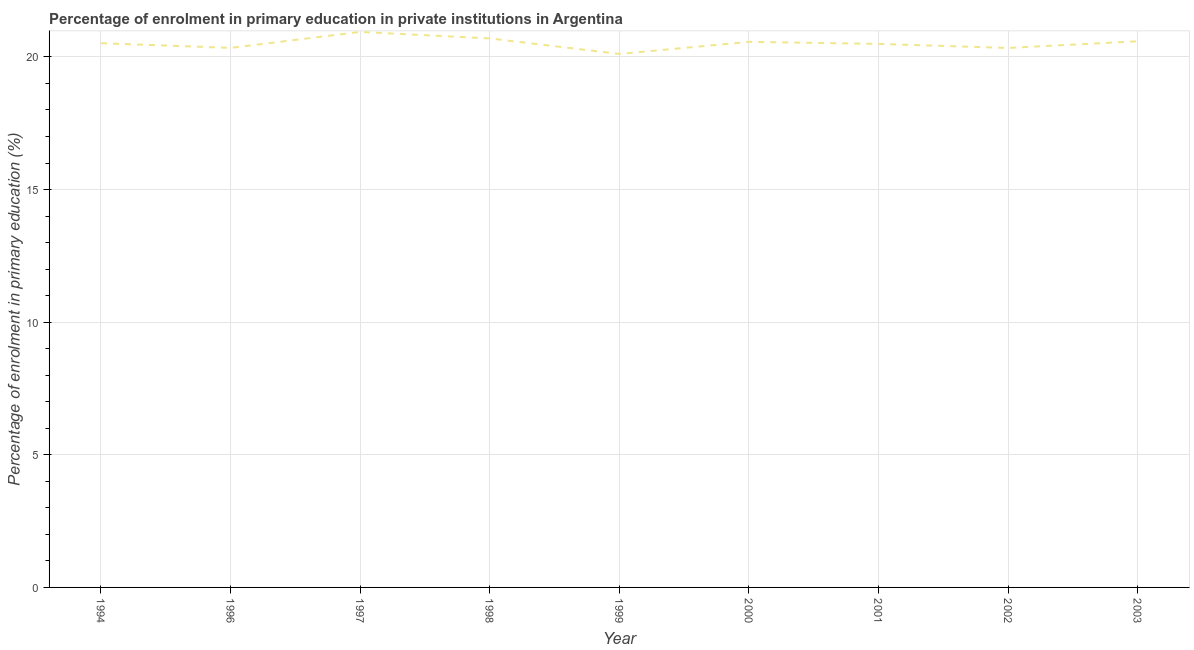What is the enrolment percentage in primary education in 1999?
Give a very brief answer. 20.11. Across all years, what is the maximum enrolment percentage in primary education?
Offer a very short reply. 20.94. Across all years, what is the minimum enrolment percentage in primary education?
Provide a succinct answer. 20.11. In which year was the enrolment percentage in primary education maximum?
Provide a short and direct response. 1997. In which year was the enrolment percentage in primary education minimum?
Your answer should be very brief. 1999. What is the sum of the enrolment percentage in primary education?
Keep it short and to the point. 184.6. What is the difference between the enrolment percentage in primary education in 1994 and 2003?
Your answer should be compact. -0.07. What is the average enrolment percentage in primary education per year?
Your response must be concise. 20.51. What is the median enrolment percentage in primary education?
Your answer should be compact. 20.52. What is the ratio of the enrolment percentage in primary education in 2002 to that in 2003?
Ensure brevity in your answer.  0.99. What is the difference between the highest and the second highest enrolment percentage in primary education?
Keep it short and to the point. 0.24. What is the difference between the highest and the lowest enrolment percentage in primary education?
Your answer should be compact. 0.83. In how many years, is the enrolment percentage in primary education greater than the average enrolment percentage in primary education taken over all years?
Provide a succinct answer. 5. Are the values on the major ticks of Y-axis written in scientific E-notation?
Provide a succinct answer. No. Does the graph contain any zero values?
Give a very brief answer. No. Does the graph contain grids?
Offer a terse response. Yes. What is the title of the graph?
Offer a very short reply. Percentage of enrolment in primary education in private institutions in Argentina. What is the label or title of the Y-axis?
Provide a short and direct response. Percentage of enrolment in primary education (%). What is the Percentage of enrolment in primary education (%) of 1994?
Provide a succinct answer. 20.52. What is the Percentage of enrolment in primary education (%) in 1996?
Offer a terse response. 20.34. What is the Percentage of enrolment in primary education (%) of 1997?
Keep it short and to the point. 20.94. What is the Percentage of enrolment in primary education (%) of 1998?
Your answer should be very brief. 20.7. What is the Percentage of enrolment in primary education (%) of 1999?
Ensure brevity in your answer.  20.11. What is the Percentage of enrolment in primary education (%) in 2000?
Keep it short and to the point. 20.57. What is the Percentage of enrolment in primary education (%) of 2001?
Offer a very short reply. 20.49. What is the Percentage of enrolment in primary education (%) of 2002?
Offer a very short reply. 20.34. What is the Percentage of enrolment in primary education (%) in 2003?
Make the answer very short. 20.59. What is the difference between the Percentage of enrolment in primary education (%) in 1994 and 1996?
Ensure brevity in your answer.  0.18. What is the difference between the Percentage of enrolment in primary education (%) in 1994 and 1997?
Make the answer very short. -0.43. What is the difference between the Percentage of enrolment in primary education (%) in 1994 and 1998?
Provide a short and direct response. -0.18. What is the difference between the Percentage of enrolment in primary education (%) in 1994 and 1999?
Your answer should be very brief. 0.41. What is the difference between the Percentage of enrolment in primary education (%) in 1994 and 2000?
Your answer should be compact. -0.05. What is the difference between the Percentage of enrolment in primary education (%) in 1994 and 2001?
Offer a very short reply. 0.03. What is the difference between the Percentage of enrolment in primary education (%) in 1994 and 2002?
Your answer should be very brief. 0.18. What is the difference between the Percentage of enrolment in primary education (%) in 1994 and 2003?
Keep it short and to the point. -0.07. What is the difference between the Percentage of enrolment in primary education (%) in 1996 and 1997?
Give a very brief answer. -0.6. What is the difference between the Percentage of enrolment in primary education (%) in 1996 and 1998?
Your answer should be very brief. -0.36. What is the difference between the Percentage of enrolment in primary education (%) in 1996 and 1999?
Your response must be concise. 0.23. What is the difference between the Percentage of enrolment in primary education (%) in 1996 and 2000?
Keep it short and to the point. -0.23. What is the difference between the Percentage of enrolment in primary education (%) in 1996 and 2001?
Provide a succinct answer. -0.15. What is the difference between the Percentage of enrolment in primary education (%) in 1996 and 2002?
Your answer should be compact. 0. What is the difference between the Percentage of enrolment in primary education (%) in 1996 and 2003?
Your answer should be very brief. -0.25. What is the difference between the Percentage of enrolment in primary education (%) in 1997 and 1998?
Offer a very short reply. 0.24. What is the difference between the Percentage of enrolment in primary education (%) in 1997 and 1999?
Give a very brief answer. 0.83. What is the difference between the Percentage of enrolment in primary education (%) in 1997 and 2000?
Keep it short and to the point. 0.37. What is the difference between the Percentage of enrolment in primary education (%) in 1997 and 2001?
Make the answer very short. 0.45. What is the difference between the Percentage of enrolment in primary education (%) in 1997 and 2002?
Make the answer very short. 0.6. What is the difference between the Percentage of enrolment in primary education (%) in 1997 and 2003?
Ensure brevity in your answer.  0.35. What is the difference between the Percentage of enrolment in primary education (%) in 1998 and 1999?
Your answer should be compact. 0.59. What is the difference between the Percentage of enrolment in primary education (%) in 1998 and 2000?
Offer a terse response. 0.13. What is the difference between the Percentage of enrolment in primary education (%) in 1998 and 2001?
Give a very brief answer. 0.21. What is the difference between the Percentage of enrolment in primary education (%) in 1998 and 2002?
Provide a short and direct response. 0.36. What is the difference between the Percentage of enrolment in primary education (%) in 1998 and 2003?
Your answer should be compact. 0.11. What is the difference between the Percentage of enrolment in primary education (%) in 1999 and 2000?
Your answer should be very brief. -0.46. What is the difference between the Percentage of enrolment in primary education (%) in 1999 and 2001?
Your response must be concise. -0.38. What is the difference between the Percentage of enrolment in primary education (%) in 1999 and 2002?
Offer a terse response. -0.23. What is the difference between the Percentage of enrolment in primary education (%) in 1999 and 2003?
Your response must be concise. -0.48. What is the difference between the Percentage of enrolment in primary education (%) in 2000 and 2001?
Your answer should be very brief. 0.08. What is the difference between the Percentage of enrolment in primary education (%) in 2000 and 2002?
Keep it short and to the point. 0.23. What is the difference between the Percentage of enrolment in primary education (%) in 2000 and 2003?
Make the answer very short. -0.02. What is the difference between the Percentage of enrolment in primary education (%) in 2001 and 2002?
Provide a short and direct response. 0.15. What is the difference between the Percentage of enrolment in primary education (%) in 2001 and 2003?
Your response must be concise. -0.1. What is the difference between the Percentage of enrolment in primary education (%) in 2002 and 2003?
Keep it short and to the point. -0.25. What is the ratio of the Percentage of enrolment in primary education (%) in 1994 to that in 2000?
Your response must be concise. 1. What is the ratio of the Percentage of enrolment in primary education (%) in 1994 to that in 2001?
Your answer should be very brief. 1. What is the ratio of the Percentage of enrolment in primary education (%) in 1994 to that in 2002?
Keep it short and to the point. 1.01. What is the ratio of the Percentage of enrolment in primary education (%) in 1996 to that in 1999?
Your response must be concise. 1.01. What is the ratio of the Percentage of enrolment in primary education (%) in 1996 to that in 2000?
Keep it short and to the point. 0.99. What is the ratio of the Percentage of enrolment in primary education (%) in 1996 to that in 2002?
Your answer should be compact. 1. What is the ratio of the Percentage of enrolment in primary education (%) in 1997 to that in 1998?
Keep it short and to the point. 1.01. What is the ratio of the Percentage of enrolment in primary education (%) in 1997 to that in 1999?
Your answer should be compact. 1.04. What is the ratio of the Percentage of enrolment in primary education (%) in 1997 to that in 2003?
Provide a succinct answer. 1.02. What is the ratio of the Percentage of enrolment in primary education (%) in 1998 to that in 1999?
Offer a very short reply. 1.03. What is the ratio of the Percentage of enrolment in primary education (%) in 1998 to that in 2000?
Your answer should be compact. 1.01. What is the ratio of the Percentage of enrolment in primary education (%) in 1998 to that in 2002?
Give a very brief answer. 1.02. What is the ratio of the Percentage of enrolment in primary education (%) in 1999 to that in 2001?
Offer a terse response. 0.98. What is the ratio of the Percentage of enrolment in primary education (%) in 2000 to that in 2002?
Your response must be concise. 1.01. What is the ratio of the Percentage of enrolment in primary education (%) in 2001 to that in 2003?
Your answer should be compact. 0.99. What is the ratio of the Percentage of enrolment in primary education (%) in 2002 to that in 2003?
Ensure brevity in your answer.  0.99. 